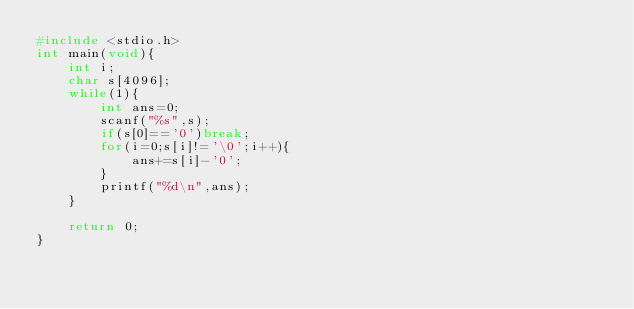Convert code to text. <code><loc_0><loc_0><loc_500><loc_500><_C_>#include <stdio.h>
int main(void){
    int i;
    char s[4096];
    while(1){
        int ans=0;
        scanf("%s",s);
        if(s[0]=='0')break;
        for(i=0;s[i]!='\0';i++){
            ans+=s[i]-'0';
        }
        printf("%d\n",ans);
    }
    
    return 0;
}

</code> 